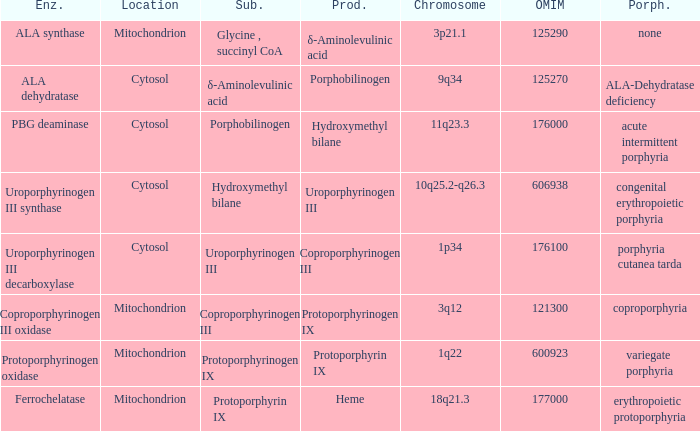What is protoporphyrin ix's substrate? Protoporphyrinogen IX. 